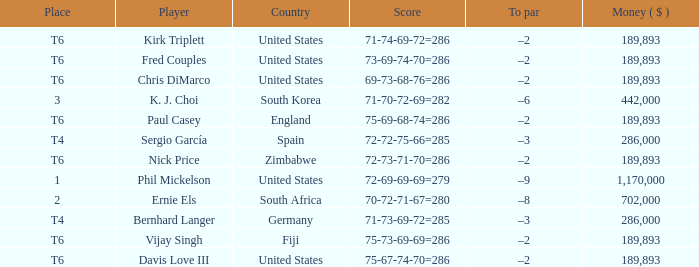What is the most money ($) when the score is 71-74-69-72=286? 189893.0. 